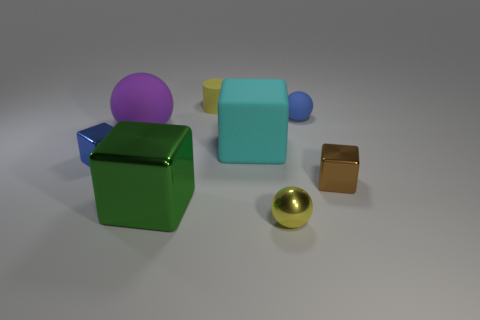Add 1 blocks. How many objects exist? 9 Subtract all spheres. How many objects are left? 5 Add 6 small blue things. How many small blue things exist? 8 Subtract 0 purple cubes. How many objects are left? 8 Subtract all large green blocks. Subtract all yellow cylinders. How many objects are left? 6 Add 4 blue metal things. How many blue metal things are left? 5 